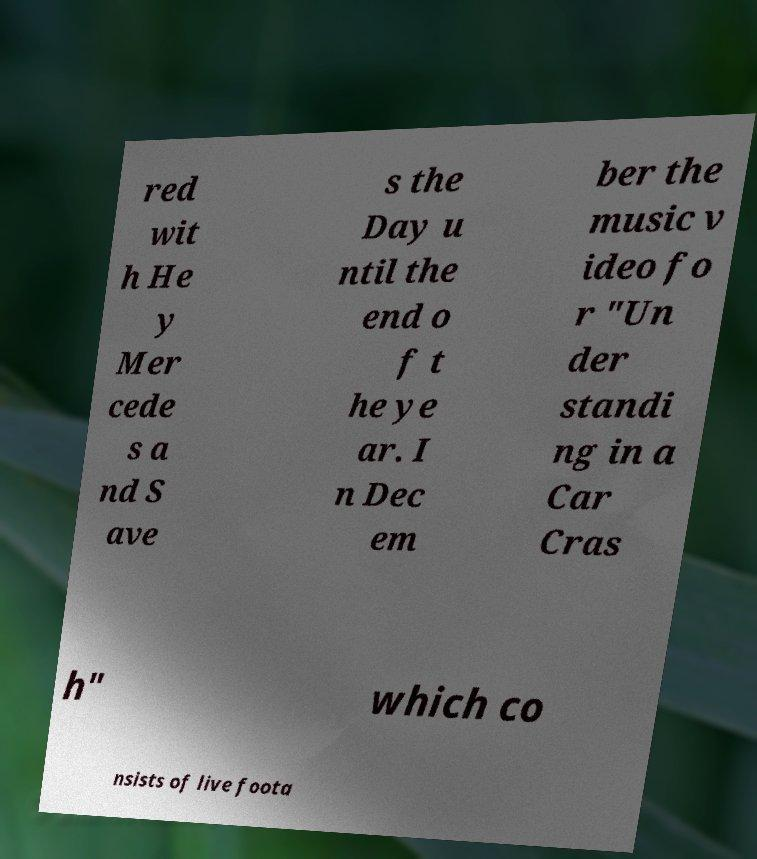Please identify and transcribe the text found in this image. red wit h He y Mer cede s a nd S ave s the Day u ntil the end o f t he ye ar. I n Dec em ber the music v ideo fo r "Un der standi ng in a Car Cras h" which co nsists of live foota 